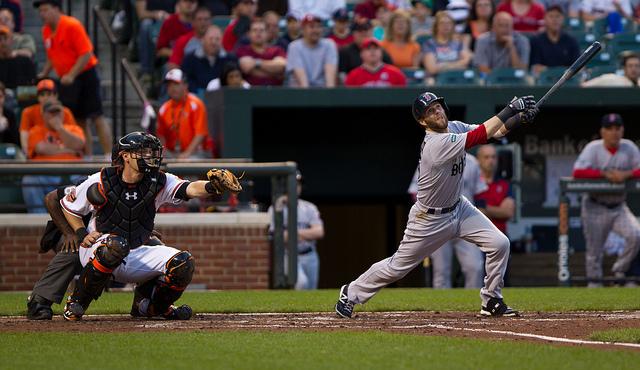Does the pitcher still have the ball?
Short answer required. No. Did the player actually hit the ball?
Answer briefly. Yes. Are both players wearing gloves?
Write a very short answer. Yes. What symbol is on the catchers vest?
Quick response, please. H. 